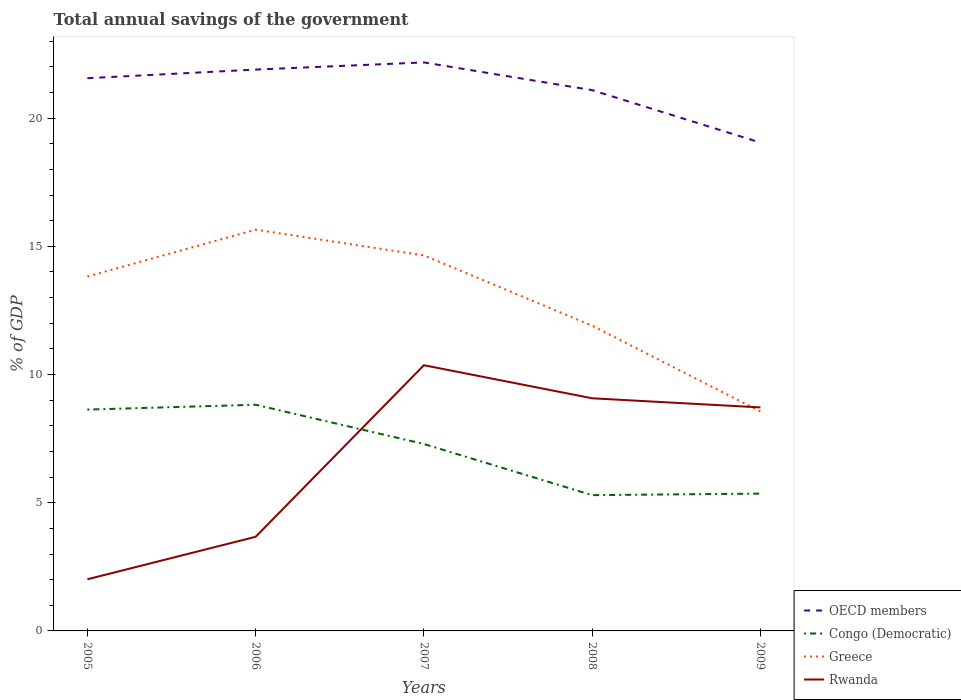Across all years, what is the maximum total annual savings of the government in Greece?
Offer a very short reply. 8.56. In which year was the total annual savings of the government in Greece maximum?
Offer a very short reply. 2009. What is the total total annual savings of the government in Rwanda in the graph?
Offer a terse response. 0.36. What is the difference between the highest and the second highest total annual savings of the government in Congo (Democratic)?
Offer a very short reply. 3.53. Is the total annual savings of the government in Congo (Democratic) strictly greater than the total annual savings of the government in OECD members over the years?
Provide a succinct answer. Yes. How many years are there in the graph?
Make the answer very short. 5. Are the values on the major ticks of Y-axis written in scientific E-notation?
Provide a short and direct response. No. Does the graph contain any zero values?
Your answer should be very brief. No. Does the graph contain grids?
Your answer should be compact. No. Where does the legend appear in the graph?
Make the answer very short. Bottom right. What is the title of the graph?
Your response must be concise. Total annual savings of the government. What is the label or title of the X-axis?
Give a very brief answer. Years. What is the label or title of the Y-axis?
Ensure brevity in your answer.  % of GDP. What is the % of GDP in OECD members in 2005?
Keep it short and to the point. 21.56. What is the % of GDP in Congo (Democratic) in 2005?
Your answer should be very brief. 8.63. What is the % of GDP in Greece in 2005?
Offer a terse response. 13.82. What is the % of GDP of Rwanda in 2005?
Ensure brevity in your answer.  2.01. What is the % of GDP in OECD members in 2006?
Your response must be concise. 21.89. What is the % of GDP in Congo (Democratic) in 2006?
Keep it short and to the point. 8.82. What is the % of GDP in Greece in 2006?
Offer a very short reply. 15.65. What is the % of GDP in Rwanda in 2006?
Your answer should be compact. 3.67. What is the % of GDP in OECD members in 2007?
Keep it short and to the point. 22.17. What is the % of GDP in Congo (Democratic) in 2007?
Offer a very short reply. 7.29. What is the % of GDP in Greece in 2007?
Provide a succinct answer. 14.65. What is the % of GDP in Rwanda in 2007?
Your answer should be very brief. 10.36. What is the % of GDP of OECD members in 2008?
Ensure brevity in your answer.  21.09. What is the % of GDP in Congo (Democratic) in 2008?
Provide a succinct answer. 5.3. What is the % of GDP of Greece in 2008?
Keep it short and to the point. 11.9. What is the % of GDP in Rwanda in 2008?
Offer a terse response. 9.07. What is the % of GDP of OECD members in 2009?
Your response must be concise. 19.05. What is the % of GDP of Congo (Democratic) in 2009?
Your answer should be very brief. 5.36. What is the % of GDP of Greece in 2009?
Keep it short and to the point. 8.56. What is the % of GDP in Rwanda in 2009?
Provide a succinct answer. 8.72. Across all years, what is the maximum % of GDP of OECD members?
Offer a very short reply. 22.17. Across all years, what is the maximum % of GDP in Congo (Democratic)?
Provide a short and direct response. 8.82. Across all years, what is the maximum % of GDP of Greece?
Keep it short and to the point. 15.65. Across all years, what is the maximum % of GDP in Rwanda?
Give a very brief answer. 10.36. Across all years, what is the minimum % of GDP of OECD members?
Make the answer very short. 19.05. Across all years, what is the minimum % of GDP in Congo (Democratic)?
Ensure brevity in your answer.  5.3. Across all years, what is the minimum % of GDP of Greece?
Provide a short and direct response. 8.56. Across all years, what is the minimum % of GDP of Rwanda?
Provide a succinct answer. 2.01. What is the total % of GDP in OECD members in the graph?
Provide a short and direct response. 105.76. What is the total % of GDP of Congo (Democratic) in the graph?
Make the answer very short. 35.4. What is the total % of GDP of Greece in the graph?
Your answer should be compact. 64.58. What is the total % of GDP of Rwanda in the graph?
Give a very brief answer. 33.84. What is the difference between the % of GDP in OECD members in 2005 and that in 2006?
Keep it short and to the point. -0.34. What is the difference between the % of GDP in Congo (Democratic) in 2005 and that in 2006?
Provide a succinct answer. -0.19. What is the difference between the % of GDP of Greece in 2005 and that in 2006?
Your response must be concise. -1.83. What is the difference between the % of GDP in Rwanda in 2005 and that in 2006?
Provide a succinct answer. -1.66. What is the difference between the % of GDP of OECD members in 2005 and that in 2007?
Your answer should be compact. -0.62. What is the difference between the % of GDP of Congo (Democratic) in 2005 and that in 2007?
Your answer should be very brief. 1.34. What is the difference between the % of GDP in Greece in 2005 and that in 2007?
Give a very brief answer. -0.82. What is the difference between the % of GDP in Rwanda in 2005 and that in 2007?
Offer a very short reply. -8.35. What is the difference between the % of GDP in OECD members in 2005 and that in 2008?
Your response must be concise. 0.47. What is the difference between the % of GDP of Congo (Democratic) in 2005 and that in 2008?
Keep it short and to the point. 3.34. What is the difference between the % of GDP of Greece in 2005 and that in 2008?
Offer a terse response. 1.92. What is the difference between the % of GDP of Rwanda in 2005 and that in 2008?
Ensure brevity in your answer.  -7.06. What is the difference between the % of GDP of OECD members in 2005 and that in 2009?
Keep it short and to the point. 2.51. What is the difference between the % of GDP in Congo (Democratic) in 2005 and that in 2009?
Give a very brief answer. 3.28. What is the difference between the % of GDP in Greece in 2005 and that in 2009?
Offer a terse response. 5.26. What is the difference between the % of GDP in Rwanda in 2005 and that in 2009?
Offer a very short reply. -6.7. What is the difference between the % of GDP of OECD members in 2006 and that in 2007?
Your answer should be compact. -0.28. What is the difference between the % of GDP in Congo (Democratic) in 2006 and that in 2007?
Your answer should be very brief. 1.53. What is the difference between the % of GDP in Rwanda in 2006 and that in 2007?
Make the answer very short. -6.69. What is the difference between the % of GDP in OECD members in 2006 and that in 2008?
Offer a terse response. 0.8. What is the difference between the % of GDP in Congo (Democratic) in 2006 and that in 2008?
Offer a terse response. 3.53. What is the difference between the % of GDP of Greece in 2006 and that in 2008?
Offer a terse response. 3.75. What is the difference between the % of GDP in Rwanda in 2006 and that in 2008?
Provide a succinct answer. -5.4. What is the difference between the % of GDP in OECD members in 2006 and that in 2009?
Provide a short and direct response. 2.85. What is the difference between the % of GDP of Congo (Democratic) in 2006 and that in 2009?
Ensure brevity in your answer.  3.47. What is the difference between the % of GDP in Greece in 2006 and that in 2009?
Make the answer very short. 7.09. What is the difference between the % of GDP in Rwanda in 2006 and that in 2009?
Your answer should be very brief. -5.05. What is the difference between the % of GDP in OECD members in 2007 and that in 2008?
Your answer should be very brief. 1.08. What is the difference between the % of GDP in Congo (Democratic) in 2007 and that in 2008?
Offer a very short reply. 1.99. What is the difference between the % of GDP in Greece in 2007 and that in 2008?
Provide a succinct answer. 2.74. What is the difference between the % of GDP in Rwanda in 2007 and that in 2008?
Your answer should be very brief. 1.29. What is the difference between the % of GDP of OECD members in 2007 and that in 2009?
Provide a succinct answer. 3.13. What is the difference between the % of GDP of Congo (Democratic) in 2007 and that in 2009?
Offer a terse response. 1.94. What is the difference between the % of GDP in Greece in 2007 and that in 2009?
Provide a succinct answer. 6.09. What is the difference between the % of GDP in Rwanda in 2007 and that in 2009?
Offer a very short reply. 1.65. What is the difference between the % of GDP in OECD members in 2008 and that in 2009?
Your answer should be very brief. 2.05. What is the difference between the % of GDP of Congo (Democratic) in 2008 and that in 2009?
Give a very brief answer. -0.06. What is the difference between the % of GDP of Greece in 2008 and that in 2009?
Provide a succinct answer. 3.35. What is the difference between the % of GDP of Rwanda in 2008 and that in 2009?
Your response must be concise. 0.36. What is the difference between the % of GDP of OECD members in 2005 and the % of GDP of Congo (Democratic) in 2006?
Ensure brevity in your answer.  12.74. What is the difference between the % of GDP of OECD members in 2005 and the % of GDP of Greece in 2006?
Your answer should be compact. 5.91. What is the difference between the % of GDP in OECD members in 2005 and the % of GDP in Rwanda in 2006?
Provide a succinct answer. 17.89. What is the difference between the % of GDP of Congo (Democratic) in 2005 and the % of GDP of Greece in 2006?
Provide a short and direct response. -7.02. What is the difference between the % of GDP in Congo (Democratic) in 2005 and the % of GDP in Rwanda in 2006?
Offer a terse response. 4.96. What is the difference between the % of GDP in Greece in 2005 and the % of GDP in Rwanda in 2006?
Your response must be concise. 10.15. What is the difference between the % of GDP in OECD members in 2005 and the % of GDP in Congo (Democratic) in 2007?
Give a very brief answer. 14.27. What is the difference between the % of GDP of OECD members in 2005 and the % of GDP of Greece in 2007?
Your answer should be very brief. 6.91. What is the difference between the % of GDP in OECD members in 2005 and the % of GDP in Rwanda in 2007?
Your answer should be compact. 11.19. What is the difference between the % of GDP of Congo (Democratic) in 2005 and the % of GDP of Greece in 2007?
Your response must be concise. -6.01. What is the difference between the % of GDP in Congo (Democratic) in 2005 and the % of GDP in Rwanda in 2007?
Keep it short and to the point. -1.73. What is the difference between the % of GDP in Greece in 2005 and the % of GDP in Rwanda in 2007?
Give a very brief answer. 3.46. What is the difference between the % of GDP of OECD members in 2005 and the % of GDP of Congo (Democratic) in 2008?
Your answer should be very brief. 16.26. What is the difference between the % of GDP of OECD members in 2005 and the % of GDP of Greece in 2008?
Ensure brevity in your answer.  9.65. What is the difference between the % of GDP in OECD members in 2005 and the % of GDP in Rwanda in 2008?
Keep it short and to the point. 12.48. What is the difference between the % of GDP in Congo (Democratic) in 2005 and the % of GDP in Greece in 2008?
Make the answer very short. -3.27. What is the difference between the % of GDP in Congo (Democratic) in 2005 and the % of GDP in Rwanda in 2008?
Offer a very short reply. -0.44. What is the difference between the % of GDP of Greece in 2005 and the % of GDP of Rwanda in 2008?
Provide a succinct answer. 4.75. What is the difference between the % of GDP in OECD members in 2005 and the % of GDP in Congo (Democratic) in 2009?
Offer a terse response. 16.2. What is the difference between the % of GDP in OECD members in 2005 and the % of GDP in Greece in 2009?
Your response must be concise. 13. What is the difference between the % of GDP of OECD members in 2005 and the % of GDP of Rwanda in 2009?
Ensure brevity in your answer.  12.84. What is the difference between the % of GDP in Congo (Democratic) in 2005 and the % of GDP in Greece in 2009?
Offer a very short reply. 0.07. What is the difference between the % of GDP in Congo (Democratic) in 2005 and the % of GDP in Rwanda in 2009?
Keep it short and to the point. -0.08. What is the difference between the % of GDP of Greece in 2005 and the % of GDP of Rwanda in 2009?
Provide a succinct answer. 5.11. What is the difference between the % of GDP of OECD members in 2006 and the % of GDP of Congo (Democratic) in 2007?
Your answer should be very brief. 14.6. What is the difference between the % of GDP of OECD members in 2006 and the % of GDP of Greece in 2007?
Make the answer very short. 7.25. What is the difference between the % of GDP of OECD members in 2006 and the % of GDP of Rwanda in 2007?
Give a very brief answer. 11.53. What is the difference between the % of GDP of Congo (Democratic) in 2006 and the % of GDP of Greece in 2007?
Your answer should be very brief. -5.83. What is the difference between the % of GDP of Congo (Democratic) in 2006 and the % of GDP of Rwanda in 2007?
Your response must be concise. -1.54. What is the difference between the % of GDP in Greece in 2006 and the % of GDP in Rwanda in 2007?
Your answer should be compact. 5.29. What is the difference between the % of GDP in OECD members in 2006 and the % of GDP in Congo (Democratic) in 2008?
Your response must be concise. 16.6. What is the difference between the % of GDP in OECD members in 2006 and the % of GDP in Greece in 2008?
Make the answer very short. 9.99. What is the difference between the % of GDP of OECD members in 2006 and the % of GDP of Rwanda in 2008?
Offer a very short reply. 12.82. What is the difference between the % of GDP in Congo (Democratic) in 2006 and the % of GDP in Greece in 2008?
Offer a terse response. -3.08. What is the difference between the % of GDP of Congo (Democratic) in 2006 and the % of GDP of Rwanda in 2008?
Ensure brevity in your answer.  -0.25. What is the difference between the % of GDP in Greece in 2006 and the % of GDP in Rwanda in 2008?
Offer a terse response. 6.58. What is the difference between the % of GDP in OECD members in 2006 and the % of GDP in Congo (Democratic) in 2009?
Provide a short and direct response. 16.54. What is the difference between the % of GDP of OECD members in 2006 and the % of GDP of Greece in 2009?
Your response must be concise. 13.34. What is the difference between the % of GDP of OECD members in 2006 and the % of GDP of Rwanda in 2009?
Your answer should be compact. 13.18. What is the difference between the % of GDP in Congo (Democratic) in 2006 and the % of GDP in Greece in 2009?
Offer a very short reply. 0.26. What is the difference between the % of GDP in Congo (Democratic) in 2006 and the % of GDP in Rwanda in 2009?
Your response must be concise. 0.1. What is the difference between the % of GDP in Greece in 2006 and the % of GDP in Rwanda in 2009?
Offer a terse response. 6.93. What is the difference between the % of GDP of OECD members in 2007 and the % of GDP of Congo (Democratic) in 2008?
Make the answer very short. 16.88. What is the difference between the % of GDP of OECD members in 2007 and the % of GDP of Greece in 2008?
Give a very brief answer. 10.27. What is the difference between the % of GDP in OECD members in 2007 and the % of GDP in Rwanda in 2008?
Make the answer very short. 13.1. What is the difference between the % of GDP in Congo (Democratic) in 2007 and the % of GDP in Greece in 2008?
Provide a short and direct response. -4.61. What is the difference between the % of GDP in Congo (Democratic) in 2007 and the % of GDP in Rwanda in 2008?
Offer a very short reply. -1.78. What is the difference between the % of GDP of Greece in 2007 and the % of GDP of Rwanda in 2008?
Give a very brief answer. 5.57. What is the difference between the % of GDP of OECD members in 2007 and the % of GDP of Congo (Democratic) in 2009?
Ensure brevity in your answer.  16.82. What is the difference between the % of GDP in OECD members in 2007 and the % of GDP in Greece in 2009?
Make the answer very short. 13.62. What is the difference between the % of GDP of OECD members in 2007 and the % of GDP of Rwanda in 2009?
Keep it short and to the point. 13.46. What is the difference between the % of GDP in Congo (Democratic) in 2007 and the % of GDP in Greece in 2009?
Your answer should be very brief. -1.27. What is the difference between the % of GDP in Congo (Democratic) in 2007 and the % of GDP in Rwanda in 2009?
Your answer should be compact. -1.43. What is the difference between the % of GDP in Greece in 2007 and the % of GDP in Rwanda in 2009?
Keep it short and to the point. 5.93. What is the difference between the % of GDP in OECD members in 2008 and the % of GDP in Congo (Democratic) in 2009?
Your answer should be compact. 15.74. What is the difference between the % of GDP of OECD members in 2008 and the % of GDP of Greece in 2009?
Keep it short and to the point. 12.53. What is the difference between the % of GDP in OECD members in 2008 and the % of GDP in Rwanda in 2009?
Your answer should be compact. 12.37. What is the difference between the % of GDP of Congo (Democratic) in 2008 and the % of GDP of Greece in 2009?
Your response must be concise. -3.26. What is the difference between the % of GDP in Congo (Democratic) in 2008 and the % of GDP in Rwanda in 2009?
Make the answer very short. -3.42. What is the difference between the % of GDP in Greece in 2008 and the % of GDP in Rwanda in 2009?
Provide a short and direct response. 3.19. What is the average % of GDP in OECD members per year?
Offer a terse response. 21.15. What is the average % of GDP of Congo (Democratic) per year?
Your answer should be very brief. 7.08. What is the average % of GDP of Greece per year?
Give a very brief answer. 12.92. What is the average % of GDP of Rwanda per year?
Your answer should be very brief. 6.77. In the year 2005, what is the difference between the % of GDP of OECD members and % of GDP of Congo (Democratic)?
Offer a terse response. 12.93. In the year 2005, what is the difference between the % of GDP of OECD members and % of GDP of Greece?
Your answer should be compact. 7.74. In the year 2005, what is the difference between the % of GDP of OECD members and % of GDP of Rwanda?
Ensure brevity in your answer.  19.54. In the year 2005, what is the difference between the % of GDP of Congo (Democratic) and % of GDP of Greece?
Keep it short and to the point. -5.19. In the year 2005, what is the difference between the % of GDP in Congo (Democratic) and % of GDP in Rwanda?
Offer a very short reply. 6.62. In the year 2005, what is the difference between the % of GDP of Greece and % of GDP of Rwanda?
Provide a succinct answer. 11.81. In the year 2006, what is the difference between the % of GDP of OECD members and % of GDP of Congo (Democratic)?
Keep it short and to the point. 13.07. In the year 2006, what is the difference between the % of GDP of OECD members and % of GDP of Greece?
Offer a very short reply. 6.25. In the year 2006, what is the difference between the % of GDP of OECD members and % of GDP of Rwanda?
Provide a short and direct response. 18.22. In the year 2006, what is the difference between the % of GDP in Congo (Democratic) and % of GDP in Greece?
Your response must be concise. -6.83. In the year 2006, what is the difference between the % of GDP in Congo (Democratic) and % of GDP in Rwanda?
Offer a very short reply. 5.15. In the year 2006, what is the difference between the % of GDP of Greece and % of GDP of Rwanda?
Make the answer very short. 11.98. In the year 2007, what is the difference between the % of GDP of OECD members and % of GDP of Congo (Democratic)?
Provide a short and direct response. 14.88. In the year 2007, what is the difference between the % of GDP in OECD members and % of GDP in Greece?
Ensure brevity in your answer.  7.53. In the year 2007, what is the difference between the % of GDP in OECD members and % of GDP in Rwanda?
Ensure brevity in your answer.  11.81. In the year 2007, what is the difference between the % of GDP in Congo (Democratic) and % of GDP in Greece?
Provide a short and direct response. -7.36. In the year 2007, what is the difference between the % of GDP of Congo (Democratic) and % of GDP of Rwanda?
Offer a terse response. -3.07. In the year 2007, what is the difference between the % of GDP in Greece and % of GDP in Rwanda?
Provide a short and direct response. 4.28. In the year 2008, what is the difference between the % of GDP of OECD members and % of GDP of Congo (Democratic)?
Make the answer very short. 15.8. In the year 2008, what is the difference between the % of GDP in OECD members and % of GDP in Greece?
Your answer should be compact. 9.19. In the year 2008, what is the difference between the % of GDP in OECD members and % of GDP in Rwanda?
Offer a terse response. 12.02. In the year 2008, what is the difference between the % of GDP in Congo (Democratic) and % of GDP in Greece?
Give a very brief answer. -6.61. In the year 2008, what is the difference between the % of GDP in Congo (Democratic) and % of GDP in Rwanda?
Your response must be concise. -3.78. In the year 2008, what is the difference between the % of GDP in Greece and % of GDP in Rwanda?
Your answer should be compact. 2.83. In the year 2009, what is the difference between the % of GDP of OECD members and % of GDP of Congo (Democratic)?
Provide a succinct answer. 13.69. In the year 2009, what is the difference between the % of GDP in OECD members and % of GDP in Greece?
Keep it short and to the point. 10.49. In the year 2009, what is the difference between the % of GDP of OECD members and % of GDP of Rwanda?
Give a very brief answer. 10.33. In the year 2009, what is the difference between the % of GDP of Congo (Democratic) and % of GDP of Greece?
Provide a short and direct response. -3.2. In the year 2009, what is the difference between the % of GDP of Congo (Democratic) and % of GDP of Rwanda?
Your answer should be very brief. -3.36. In the year 2009, what is the difference between the % of GDP in Greece and % of GDP in Rwanda?
Your answer should be very brief. -0.16. What is the ratio of the % of GDP in OECD members in 2005 to that in 2006?
Offer a terse response. 0.98. What is the ratio of the % of GDP in Congo (Democratic) in 2005 to that in 2006?
Provide a short and direct response. 0.98. What is the ratio of the % of GDP of Greece in 2005 to that in 2006?
Provide a succinct answer. 0.88. What is the ratio of the % of GDP of Rwanda in 2005 to that in 2006?
Ensure brevity in your answer.  0.55. What is the ratio of the % of GDP in OECD members in 2005 to that in 2007?
Your response must be concise. 0.97. What is the ratio of the % of GDP of Congo (Democratic) in 2005 to that in 2007?
Provide a succinct answer. 1.18. What is the ratio of the % of GDP in Greece in 2005 to that in 2007?
Offer a terse response. 0.94. What is the ratio of the % of GDP in Rwanda in 2005 to that in 2007?
Provide a short and direct response. 0.19. What is the ratio of the % of GDP in OECD members in 2005 to that in 2008?
Your response must be concise. 1.02. What is the ratio of the % of GDP of Congo (Democratic) in 2005 to that in 2008?
Offer a terse response. 1.63. What is the ratio of the % of GDP of Greece in 2005 to that in 2008?
Give a very brief answer. 1.16. What is the ratio of the % of GDP in Rwanda in 2005 to that in 2008?
Keep it short and to the point. 0.22. What is the ratio of the % of GDP in OECD members in 2005 to that in 2009?
Give a very brief answer. 1.13. What is the ratio of the % of GDP in Congo (Democratic) in 2005 to that in 2009?
Provide a short and direct response. 1.61. What is the ratio of the % of GDP in Greece in 2005 to that in 2009?
Provide a succinct answer. 1.62. What is the ratio of the % of GDP of Rwanda in 2005 to that in 2009?
Offer a terse response. 0.23. What is the ratio of the % of GDP of OECD members in 2006 to that in 2007?
Your response must be concise. 0.99. What is the ratio of the % of GDP in Congo (Democratic) in 2006 to that in 2007?
Your response must be concise. 1.21. What is the ratio of the % of GDP of Greece in 2006 to that in 2007?
Your answer should be compact. 1.07. What is the ratio of the % of GDP of Rwanda in 2006 to that in 2007?
Offer a terse response. 0.35. What is the ratio of the % of GDP in OECD members in 2006 to that in 2008?
Your answer should be very brief. 1.04. What is the ratio of the % of GDP in Congo (Democratic) in 2006 to that in 2008?
Offer a terse response. 1.67. What is the ratio of the % of GDP in Greece in 2006 to that in 2008?
Your answer should be very brief. 1.31. What is the ratio of the % of GDP in Rwanda in 2006 to that in 2008?
Ensure brevity in your answer.  0.4. What is the ratio of the % of GDP in OECD members in 2006 to that in 2009?
Offer a very short reply. 1.15. What is the ratio of the % of GDP in Congo (Democratic) in 2006 to that in 2009?
Offer a terse response. 1.65. What is the ratio of the % of GDP of Greece in 2006 to that in 2009?
Provide a succinct answer. 1.83. What is the ratio of the % of GDP in Rwanda in 2006 to that in 2009?
Your answer should be very brief. 0.42. What is the ratio of the % of GDP of OECD members in 2007 to that in 2008?
Offer a terse response. 1.05. What is the ratio of the % of GDP in Congo (Democratic) in 2007 to that in 2008?
Your answer should be compact. 1.38. What is the ratio of the % of GDP of Greece in 2007 to that in 2008?
Offer a very short reply. 1.23. What is the ratio of the % of GDP of Rwanda in 2007 to that in 2008?
Offer a terse response. 1.14. What is the ratio of the % of GDP of OECD members in 2007 to that in 2009?
Provide a succinct answer. 1.16. What is the ratio of the % of GDP in Congo (Democratic) in 2007 to that in 2009?
Ensure brevity in your answer.  1.36. What is the ratio of the % of GDP in Greece in 2007 to that in 2009?
Your answer should be very brief. 1.71. What is the ratio of the % of GDP of Rwanda in 2007 to that in 2009?
Make the answer very short. 1.19. What is the ratio of the % of GDP in OECD members in 2008 to that in 2009?
Your answer should be compact. 1.11. What is the ratio of the % of GDP of Congo (Democratic) in 2008 to that in 2009?
Keep it short and to the point. 0.99. What is the ratio of the % of GDP in Greece in 2008 to that in 2009?
Give a very brief answer. 1.39. What is the ratio of the % of GDP in Rwanda in 2008 to that in 2009?
Provide a succinct answer. 1.04. What is the difference between the highest and the second highest % of GDP in OECD members?
Provide a short and direct response. 0.28. What is the difference between the highest and the second highest % of GDP in Congo (Democratic)?
Provide a succinct answer. 0.19. What is the difference between the highest and the second highest % of GDP of Rwanda?
Ensure brevity in your answer.  1.29. What is the difference between the highest and the lowest % of GDP in OECD members?
Give a very brief answer. 3.13. What is the difference between the highest and the lowest % of GDP of Congo (Democratic)?
Offer a very short reply. 3.53. What is the difference between the highest and the lowest % of GDP of Greece?
Keep it short and to the point. 7.09. What is the difference between the highest and the lowest % of GDP of Rwanda?
Your answer should be compact. 8.35. 